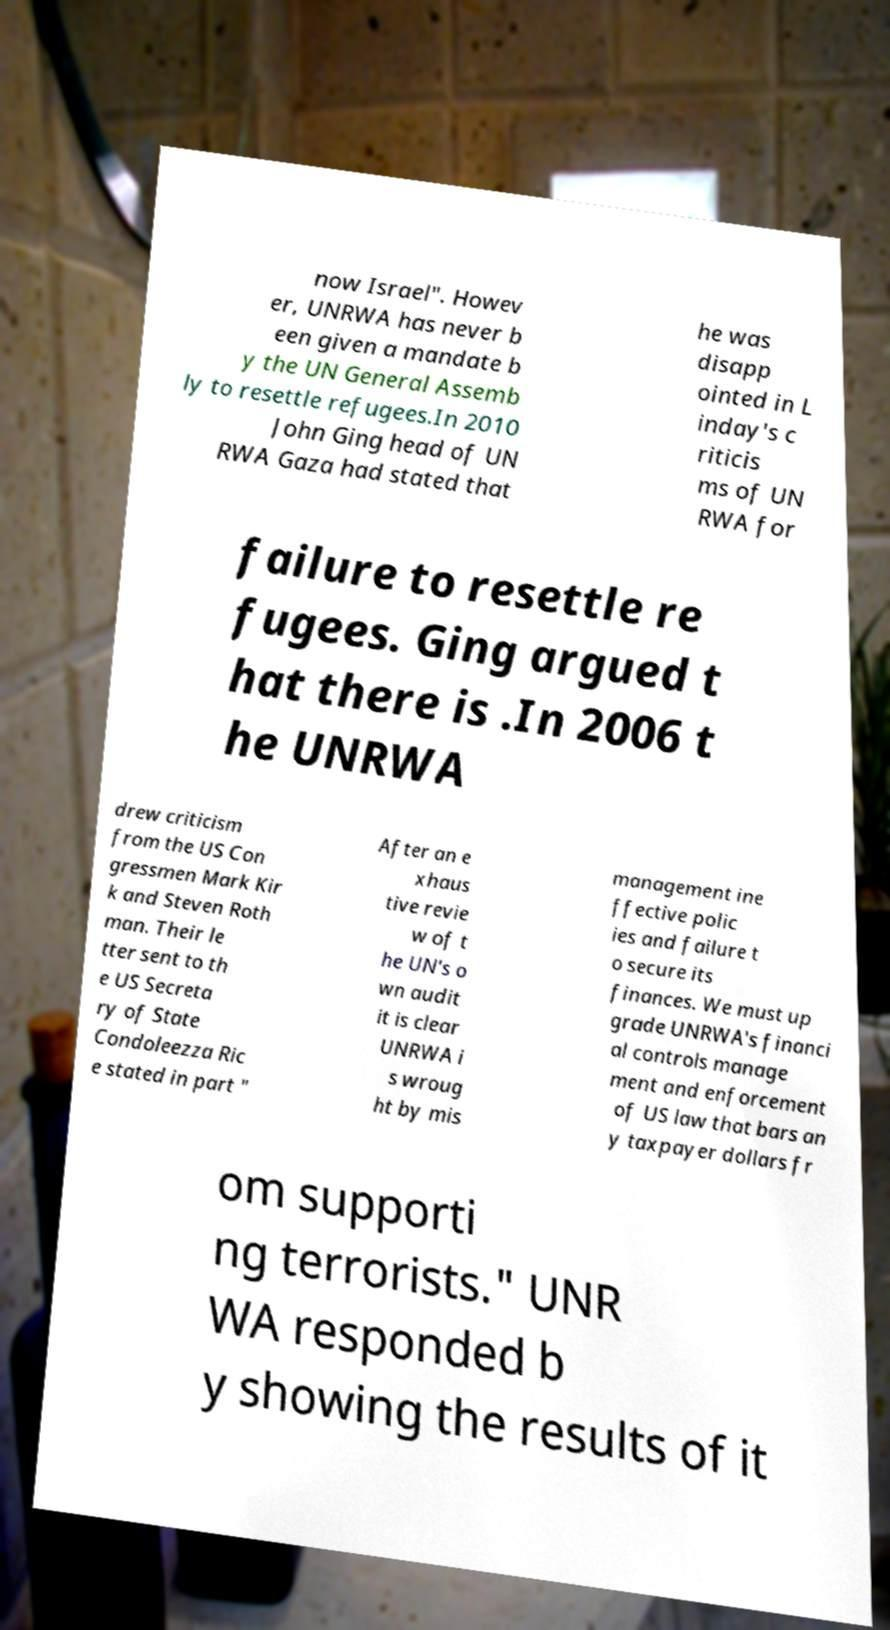Could you assist in decoding the text presented in this image and type it out clearly? now Israel". Howev er, UNRWA has never b een given a mandate b y the UN General Assemb ly to resettle refugees.In 2010 John Ging head of UN RWA Gaza had stated that he was disapp ointed in L inday's c riticis ms of UN RWA for failure to resettle re fugees. Ging argued t hat there is .In 2006 t he UNRWA drew criticism from the US Con gressmen Mark Kir k and Steven Roth man. Their le tter sent to th e US Secreta ry of State Condoleezza Ric e stated in part " After an e xhaus tive revie w of t he UN's o wn audit it is clear UNRWA i s wroug ht by mis management ine ffective polic ies and failure t o secure its finances. We must up grade UNRWA's financi al controls manage ment and enforcement of US law that bars an y taxpayer dollars fr om supporti ng terrorists." UNR WA responded b y showing the results of it 